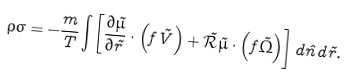Convert formula to latex. <formula><loc_0><loc_0><loc_500><loc_500>\rho \sigma = - \frac { m } { T } \int \left [ \frac { \partial \tilde { \mu } } { \partial \vec { r } } \cdot \left ( f \vec { V } \right ) + \vec { \mathcal { R } } \tilde { \mu } \cdot \left ( f \vec { \Omega } \right ) \right ] d \hat { n } d \vec { r } .</formula> 